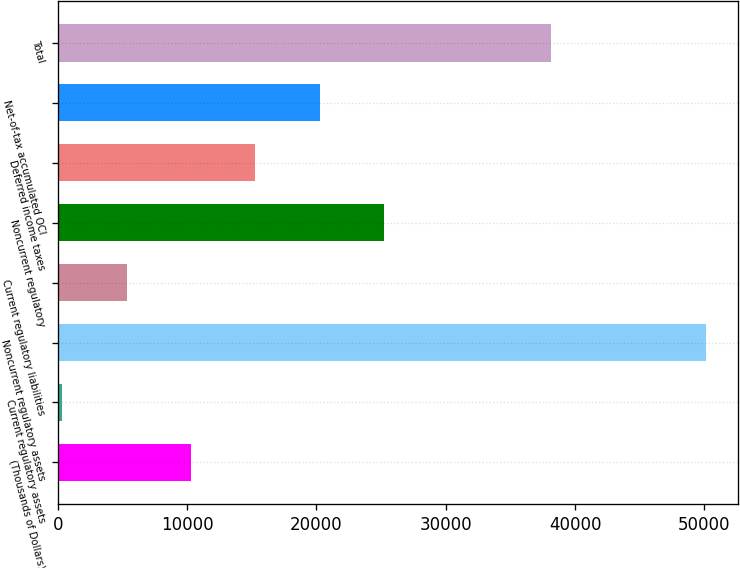<chart> <loc_0><loc_0><loc_500><loc_500><bar_chart><fcel>(Thousands of Dollars)<fcel>Current regulatory assets<fcel>Noncurrent regulatory assets<fcel>Current regulatory liabilities<fcel>Noncurrent regulatory<fcel>Deferred income taxes<fcel>Net-of-tax accumulated OCI<fcel>Total<nl><fcel>10308.6<fcel>352<fcel>50135<fcel>5330.3<fcel>25243.5<fcel>15286.9<fcel>20265.2<fcel>38114<nl></chart> 